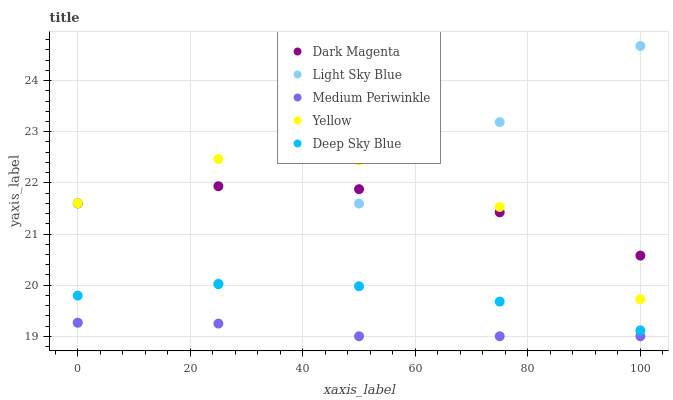Does Medium Periwinkle have the minimum area under the curve?
Answer yes or no. Yes. Does Yellow have the maximum area under the curve?
Answer yes or no. Yes. Does Light Sky Blue have the minimum area under the curve?
Answer yes or no. No. Does Light Sky Blue have the maximum area under the curve?
Answer yes or no. No. Is Medium Periwinkle the smoothest?
Answer yes or no. Yes. Is Yellow the roughest?
Answer yes or no. Yes. Is Light Sky Blue the smoothest?
Answer yes or no. No. Is Light Sky Blue the roughest?
Answer yes or no. No. Does Medium Periwinkle have the lowest value?
Answer yes or no. Yes. Does Light Sky Blue have the lowest value?
Answer yes or no. No. Does Light Sky Blue have the highest value?
Answer yes or no. Yes. Does Medium Periwinkle have the highest value?
Answer yes or no. No. Is Medium Periwinkle less than Dark Magenta?
Answer yes or no. Yes. Is Yellow greater than Deep Sky Blue?
Answer yes or no. Yes. Does Light Sky Blue intersect Dark Magenta?
Answer yes or no. Yes. Is Light Sky Blue less than Dark Magenta?
Answer yes or no. No. Is Light Sky Blue greater than Dark Magenta?
Answer yes or no. No. Does Medium Periwinkle intersect Dark Magenta?
Answer yes or no. No. 